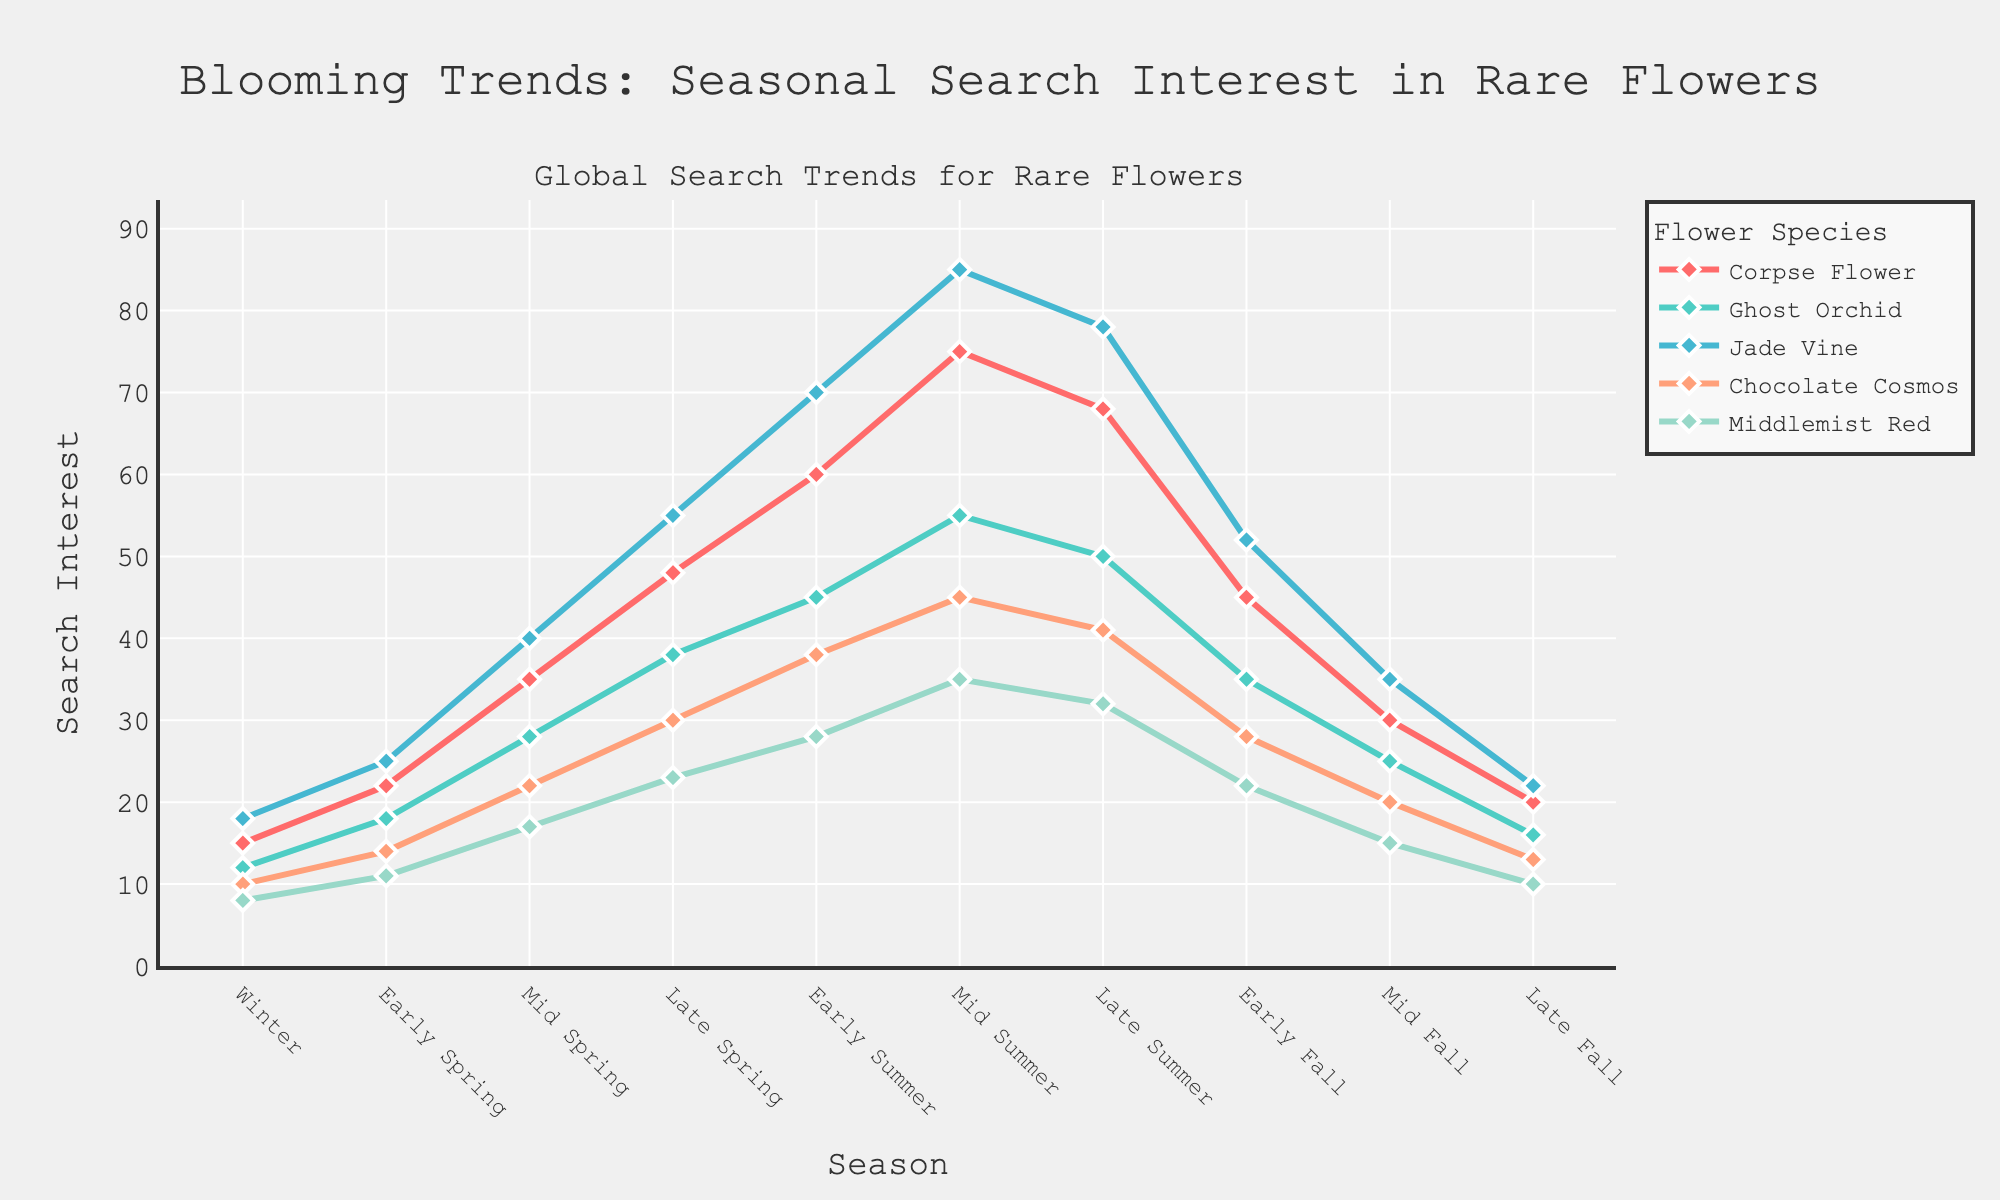Which flower species has the highest search interest during Early Summer? Examine the line chart at the Early Summer point, and observe which flower species has the tallest peak. The flower species with the highest search interest during Early Summer is Jade Vine with a value of 70.
Answer: Jade Vine During which season does the Ghost Orchid reach its peak search interest? Follow the line representing Ghost Orchid and identify the seasonal point where it reaches the highest value. The Ghost Orchid reaches its peak search interest in Mid Summer with a value of 55.
Answer: Mid Summer Which flower species has the steepest increase in search interest from Winter to Mid Spring? Analyze the slopes of all the lines representing the flower species from Winter to Mid Spring. Determine the flower with the steepest rise. The Jade Vine shows the steepest increase from 18 to 40.
Answer: Jade Vine How does the search interest for Corpse Flower in Late Spring compare to that in Late Summer? Locate the Corpse Flower's line at the Late Spring (48) and Late Summer (68) points. Compare the two values: 68 > 48.
Answer: Late Summer is higher than Late Spring Which flower shows a decline in search interest from Mid Summer to Late Summer? Follow the trends for each flower species from Mid Summer to Late Summer. Identify any lines that show a downward trend. Both Jade Vine and Ghost Orchid show a decline.
Answer: Jade Vine and Ghost Orchid What is the average search interest for Chocolate Cosmos throughout the Fall seasons? Identify the values for Chocolate Cosmos in Early Fall (28), Mid Fall (20), and Late Fall (13). Compute the average: (28 + 20 + 13) / 3 = 61 / 3 approximately equals 20.33.
Answer: 20.33 Is there any season where all flower species have the lowest search interest values? Examine all the flowers across different seasons and identify if there's a season where all flowers have their lowest values simultaneously. The lowest interest season is Winter, but it's not uniformly the lowest for all. Late Fall shows uniformly low values.
Answer: Late Fall 